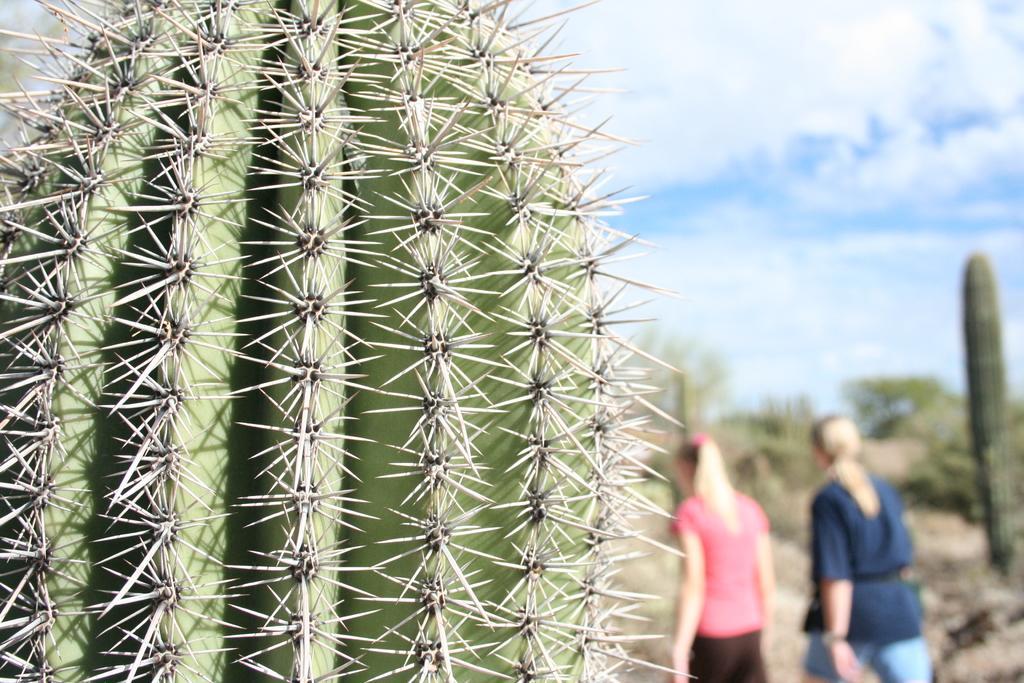In one or two sentences, can you explain what this image depicts? In this image I can see a cactus plant which is in green color, background I can see two persons walking and the person at left wearing pink shirt, black pant and the person at right wearing blue shirt, blue pant. Background I can see the sky in blue and white color. 